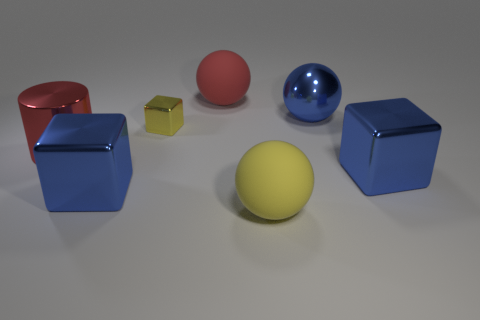Is there any other thing that is the same size as the yellow metallic block?
Offer a terse response. No. Are there any other things that have the same shape as the red metallic thing?
Your answer should be compact. No. What size is the red ball that is made of the same material as the large yellow sphere?
Your answer should be very brief. Large. There is a big rubber ball behind the large blue shiny cube on the right side of the big yellow matte thing; is there a big yellow matte thing in front of it?
Your response must be concise. Yes. There is a blue block that is to the left of the shiny ball; does it have the same size as the big yellow matte ball?
Your answer should be compact. Yes. What number of blue metal blocks are the same size as the yellow matte sphere?
Provide a short and direct response. 2. The sphere that is the same color as the cylinder is what size?
Make the answer very short. Large. Is the color of the tiny thing the same as the large metal ball?
Provide a succinct answer. No. There is a tiny yellow shiny thing; what shape is it?
Offer a very short reply. Cube. Is there a large metallic thing of the same color as the large metallic cylinder?
Give a very brief answer. No. 